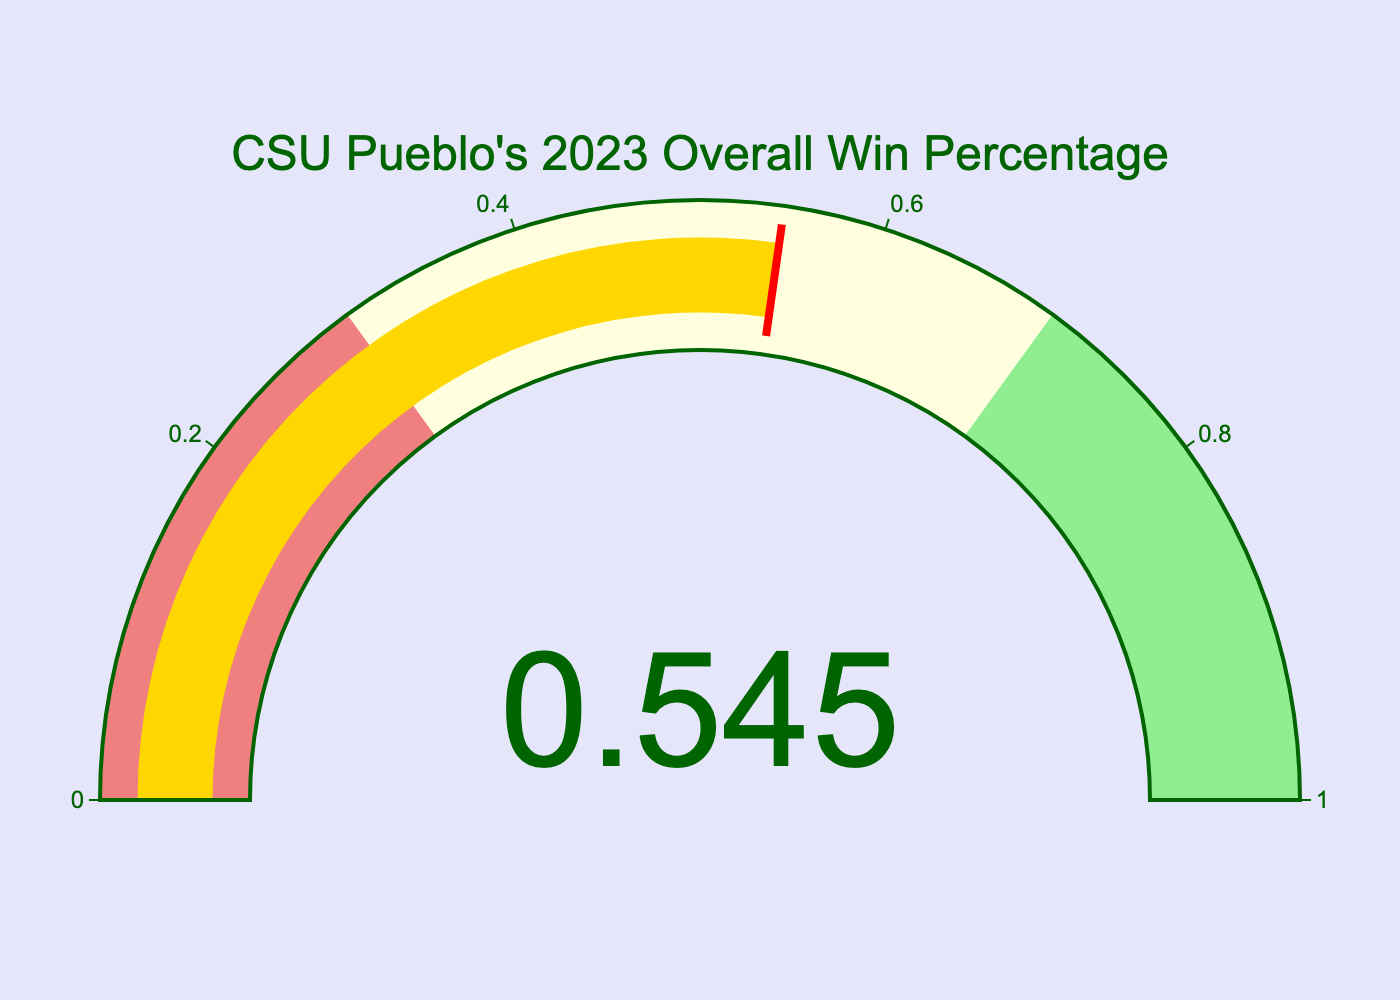what is the title of the gauge chart? The title is clearly displayed at the top of the gauge chart.
Answer: CSU Pueblo's 2023 Overall Win Percentage What percentage value does the gauge indicate? The number is displayed in the center of the gauge indicating the win percentage.
Answer: 54.5% What is the maximum value on the gauge chart's scale? The scale on the gauge is marked from 0 to 1, as indicated on the chart.
Answer: 1 In what color is the bar indicating the win percentage filled? The segment indicating the win percentage is filled with a noticeable color.
Answer: gold What range does the light yellow color represent on the gauge chart? The light yellow segment's range is marked on the gauge chart between certain values.
Answer: 0.3 to 0.7 Is the current win percentage closer to the high end or low end of the light yellow range? The indicated win percentage of 0.545 falls within the light yellow range, so we compare it to the defined ends of the range.
Answer: Closer to the high end What visual elements signify the thresholds on the gauge chart? The threshold is indicated by a specific line on the gauge.
Answer: red line What is the background color of the gauge chart? The background color setting of the gauge chart is visible behind the graphical elements.
Answer: white What color represents the lowest range on the gauge chart? The color coding indicates values within a certain range.
Answer: lightcoral What is the width of the threshold line on the gauge chart? The visual description of the line's width can be identified by its appearance.
Answer: 4 